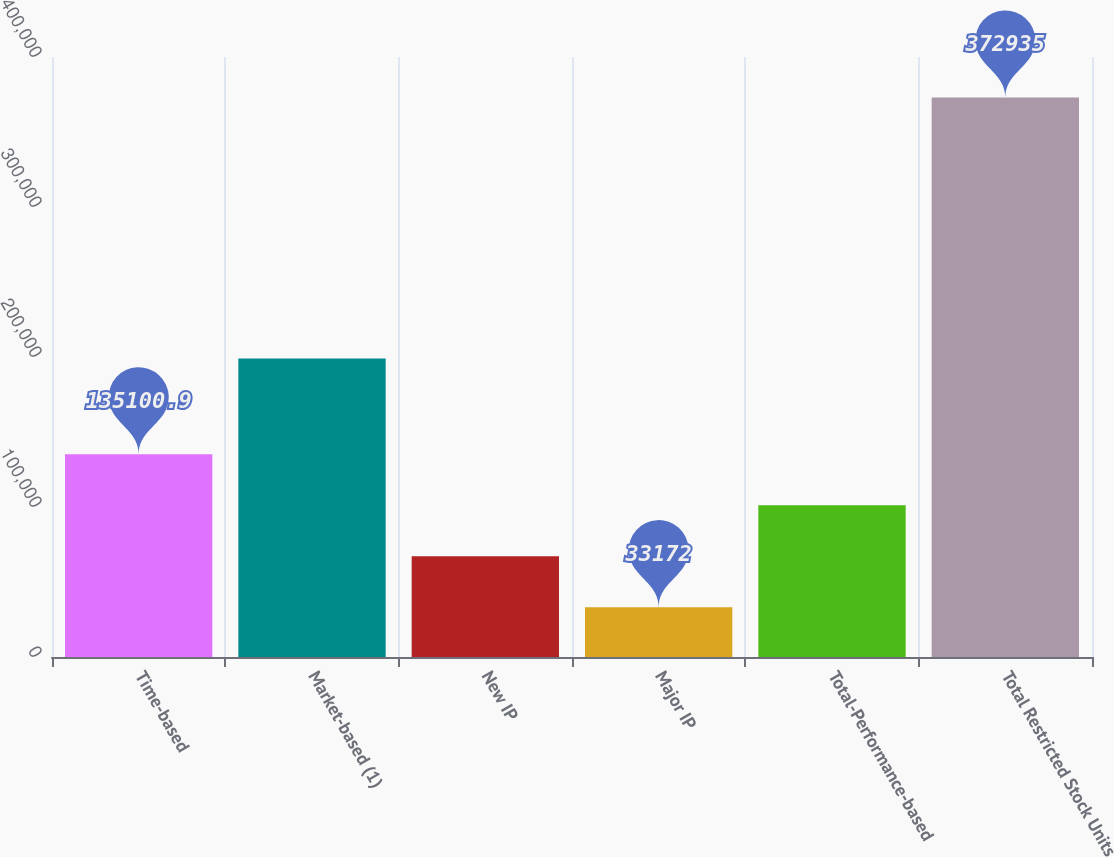<chart> <loc_0><loc_0><loc_500><loc_500><bar_chart><fcel>Time-based<fcel>Market-based (1)<fcel>New IP<fcel>Major IP<fcel>Total-Performance-based<fcel>Total Restricted Stock Units<nl><fcel>135101<fcel>199038<fcel>67148.3<fcel>33172<fcel>101125<fcel>372935<nl></chart> 